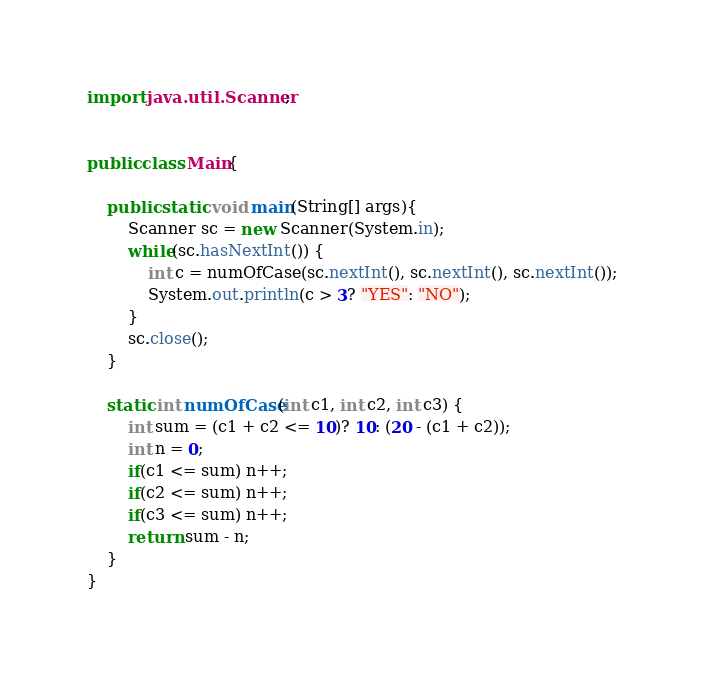<code> <loc_0><loc_0><loc_500><loc_500><_Java_>import java.util.Scanner;


public class Main{
	
	public static void main(String[] args){
		Scanner sc = new Scanner(System.in);
		while(sc.hasNextInt()) {
			int c = numOfCase(sc.nextInt(), sc.nextInt(), sc.nextInt());
			System.out.println(c > 3? "YES": "NO");
		}
		sc.close();
	}
	
	static int numOfCase(int c1, int c2, int c3) {
		int sum = (c1 + c2 <= 10)? 10: (20 - (c1 + c2));
		int n = 0;
		if(c1 <= sum) n++;
		if(c2 <= sum) n++;
		if(c3 <= sum) n++;
		return sum - n;
	}
}</code> 